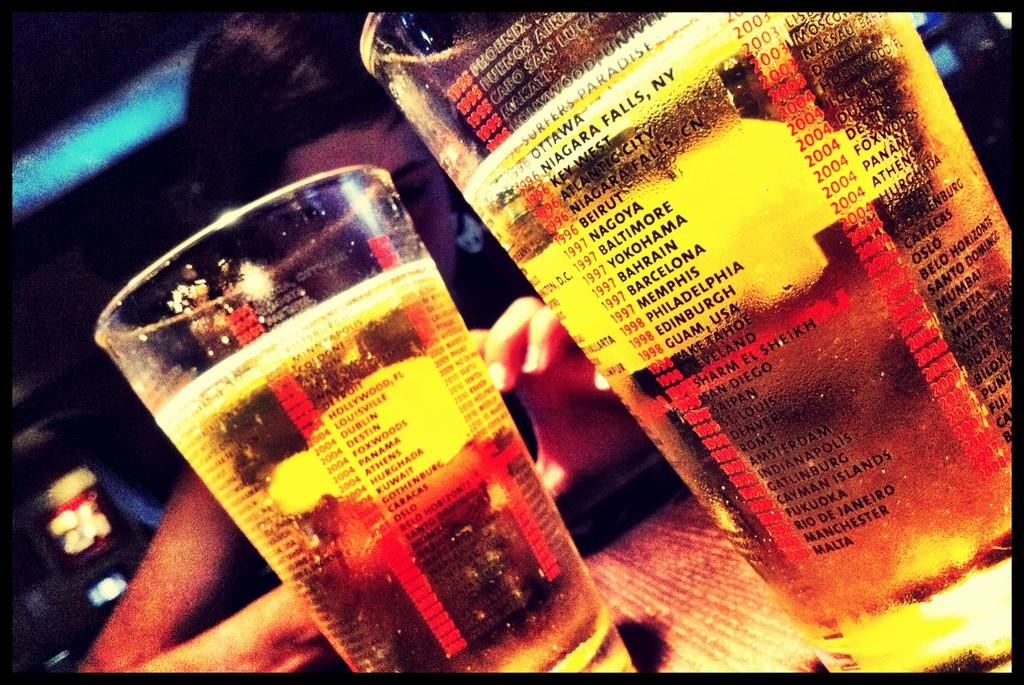Provide a one-sentence caption for the provided image. two cups that have lists of years and city names listed on them. 